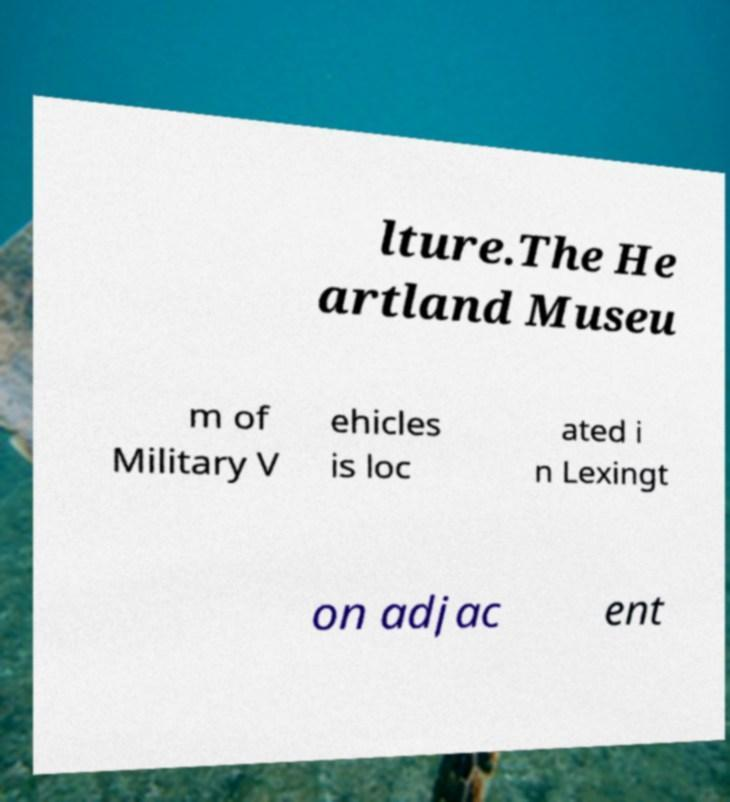Could you extract and type out the text from this image? lture.The He artland Museu m of Military V ehicles is loc ated i n Lexingt on adjac ent 